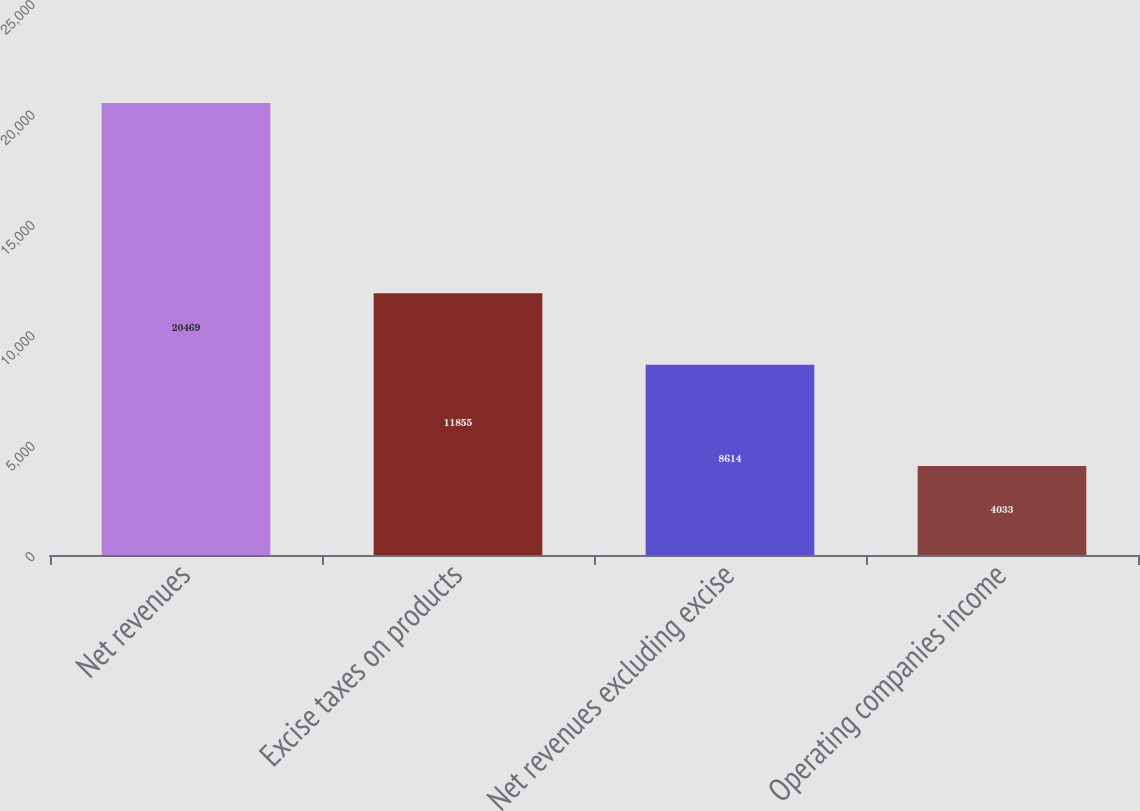Convert chart. <chart><loc_0><loc_0><loc_500><loc_500><bar_chart><fcel>Net revenues<fcel>Excise taxes on products<fcel>Net revenues excluding excise<fcel>Operating companies income<nl><fcel>20469<fcel>11855<fcel>8614<fcel>4033<nl></chart> 